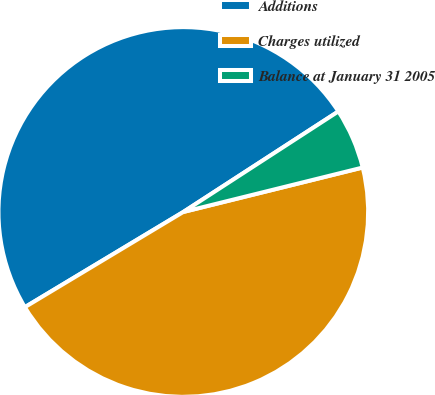Convert chart to OTSL. <chart><loc_0><loc_0><loc_500><loc_500><pie_chart><fcel>Additions<fcel>Charges utilized<fcel>Balance at January 31 2005<nl><fcel>49.46%<fcel>45.26%<fcel>5.29%<nl></chart> 